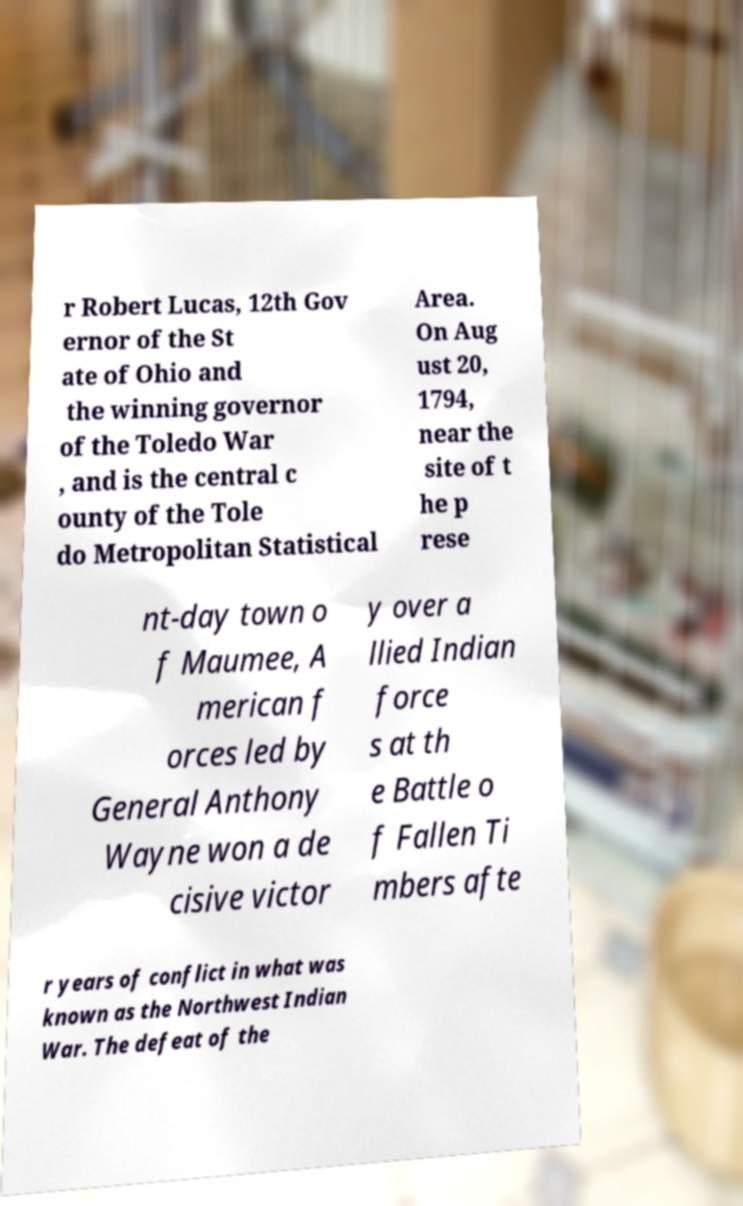There's text embedded in this image that I need extracted. Can you transcribe it verbatim? r Robert Lucas, 12th Gov ernor of the St ate of Ohio and the winning governor of the Toledo War , and is the central c ounty of the Tole do Metropolitan Statistical Area. On Aug ust 20, 1794, near the site of t he p rese nt-day town o f Maumee, A merican f orces led by General Anthony Wayne won a de cisive victor y over a llied Indian force s at th e Battle o f Fallen Ti mbers afte r years of conflict in what was known as the Northwest Indian War. The defeat of the 